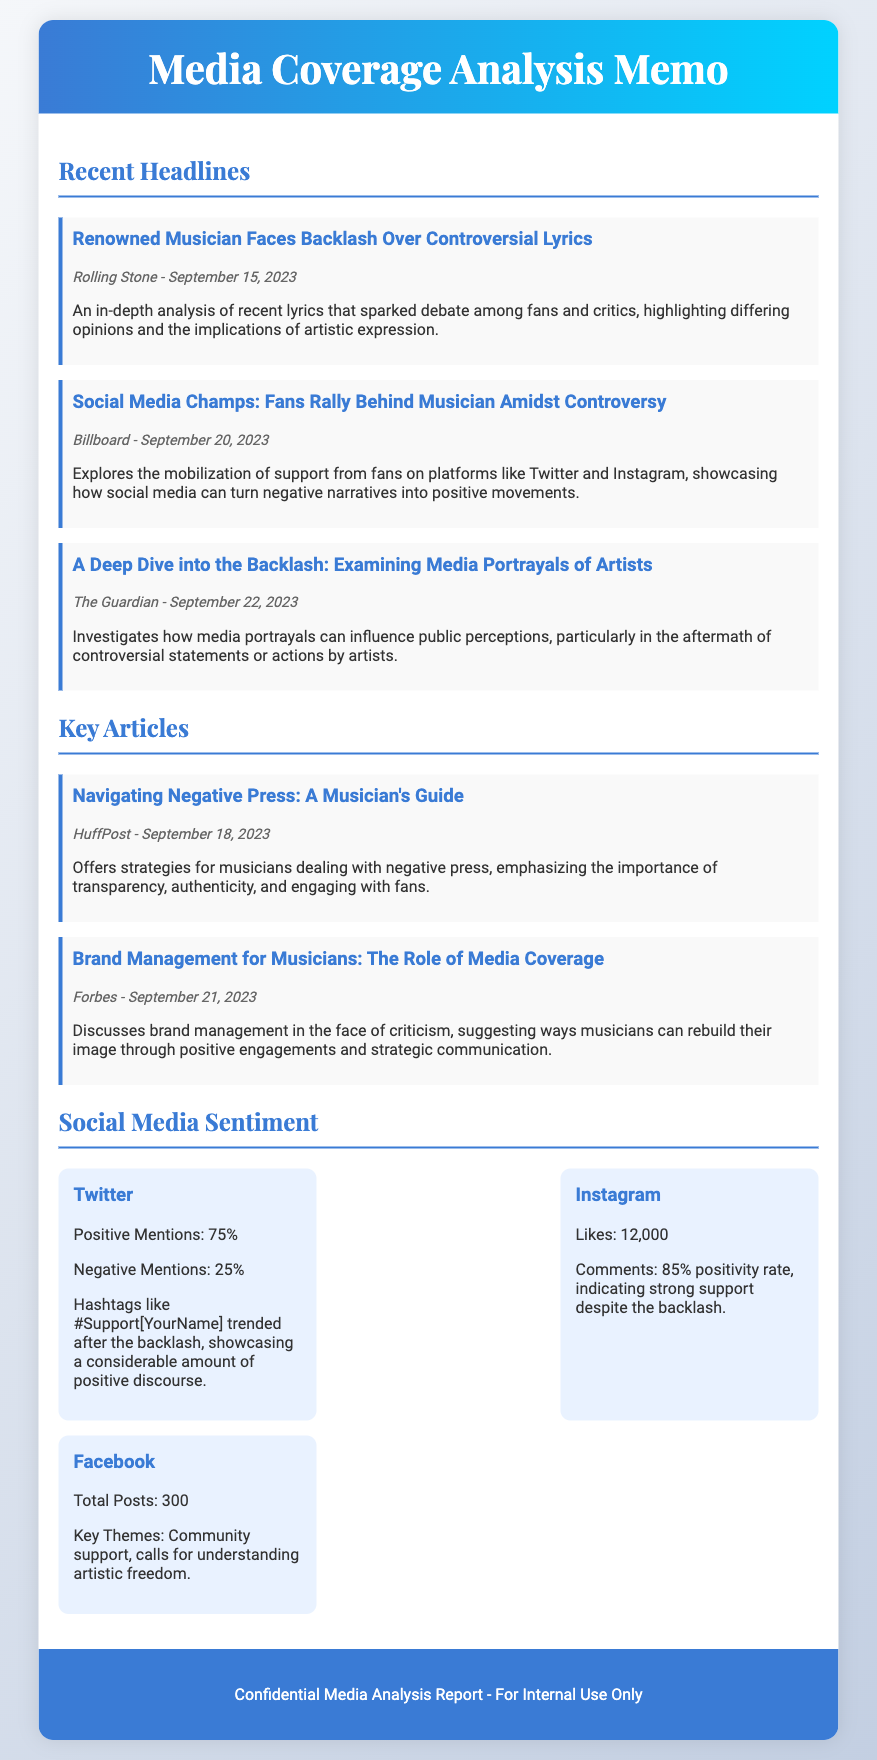what is the date of the Rolling Stone article? The article titled "Renowned Musician Faces Backlash Over Controversial Lyrics" was published on September 15, 2023.
Answer: September 15, 2023 who authored the HuffPost article? The article titled "Navigating Negative Press: A Musician's Guide" was published by HuffPost.
Answer: HuffPost what percentage of Twitter mentions were positive? According to the social media sentiment section, 75% of Twitter mentions were positive.
Answer: 75% what is the positivity rate of comments on Instagram? The sentiment analysis indicates that Instagram has an 85% positivity rate in comments.
Answer: 85% what is the title of the Billboard article? The headline of the article from Billboard is "Social Media Champs: Fans Rally Behind Musician Amidst Controversy."
Answer: Social Media Champs: Fans Rally Behind Musician Amidst Controversy how many total posts were made on Facebook? The document states that there were a total of 300 posts on Facebook.
Answer: 300 what are the key themes mentioned for Facebook? The social media sentiment analysis highlights that the key themes on Facebook were community support and calls for understanding artistic freedom.
Answer: Community support, calls for understanding artistic freedom what type of analysis is featured in The Guardian article? The Guardian article focuses on examining media portrayals of artists and their influence on public perception.
Answer: Examining media portrayals of artists what is the publication date of the Forbes article? The article titled "Brand Management for Musicians: The Role of Media Coverage" was published on September 21, 2023.
Answer: September 21, 2023 